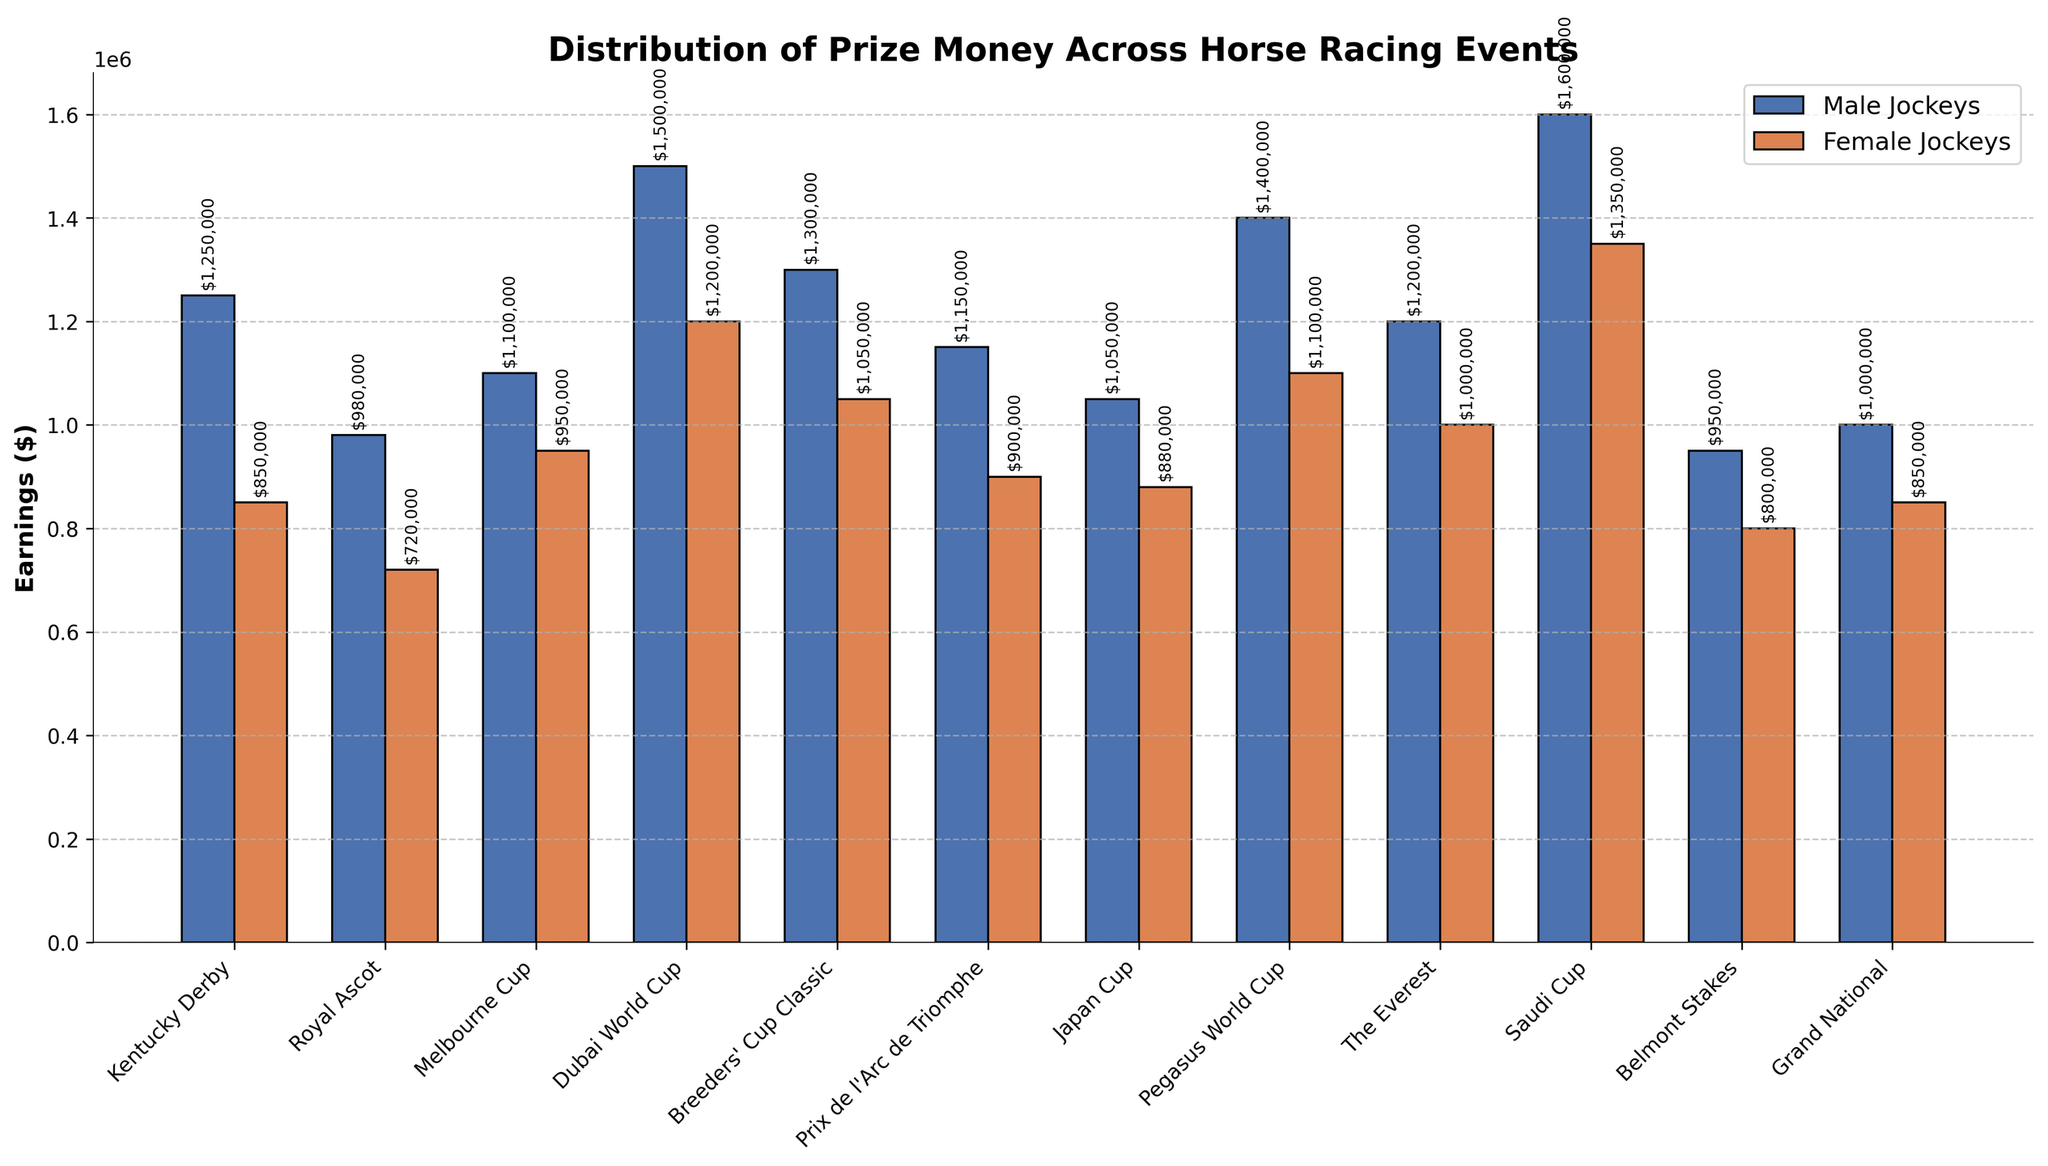Which horse racing event has the highest earnings for male jockeys? We look at the height of the blue bars representing male jockey earnings and identify the tallest one. The tallest blue bar corresponds to the Saudi Cup.
Answer: Saudi Cup What's the difference in earnings between male and female jockeys in the Dubai World Cup? We find the earnings for male and female jockeys in the Dubai World Cup from the respective bars. Male jockeys earn $1,500,000, and female jockeys earn $1,200,000. The difference is $1,500,000 - $1,200,000.
Answer: $300,000 Which event shows the smallest earnings gap between male and female jockeys? We compare the differences between the heights of the blue and red bars for each event. The smallest gap is seen at the Melbourne Cup, where the difference is relatively small compared to other events.
Answer: Melbourne Cup What is the total prize money for male jockeys in all events combined? We sum up all the earnings for male jockeys across all events. Namely, $1,250,000 + $980,000 + $1,100,000 + $1,500,000 + $1,300,000 + $1,150,000 + $1,050,000 + $1,400,000 + $1,200,000 + $1,600,000 + $950,000 + $1,000,000. The total is $14,480,000.
Answer: $14,480,000 Are there any events where female jockey earnings surpass male jockey earnings? We visually inspect the figure to see if any red bar (female jockey) is taller than the corresponding blue bar (male jockey). None of the red bars surpass the blue bars in height.
Answer: No Which event has the closest earning for male and female jockeys? We compare the differences between male and female jockeys' earnings across all events. The minimal difference is observed in the Melbourne Cup.
Answer: Melbourne Cup What's the average earnings for male jockeys across all events? We sum up all the earnings for male jockeys ($14,480,000) and divide by the number of events (12). The average is $14,480,000 / 12.
Answer: $1,206,667 How much more do male jockeys earn on average compared to female jockeys in the Royal Ascot? Male jockeys earn $980,000, and female jockeys earn $720,000 in Royal Ascot. The difference is $980,000 - $720,000.
Answer: $260,000 Which event has the highest earnings for female jockeys? We look at the height of the red bars representing female jockey earnings and identify the tallest one. The tallest red bar corresponds to the Saudi Cup.
Answer: Saudi Cup What's the total prize money for both male and female jockeys in the Kentucky Derby? We sum the earnings for male and female jockeys in the Kentucky Derby. Male jockeys earn $1,250,000 and female jockeys earn $850,000. The total is $1,250,000 + $850,000.
Answer: $2,100,000 